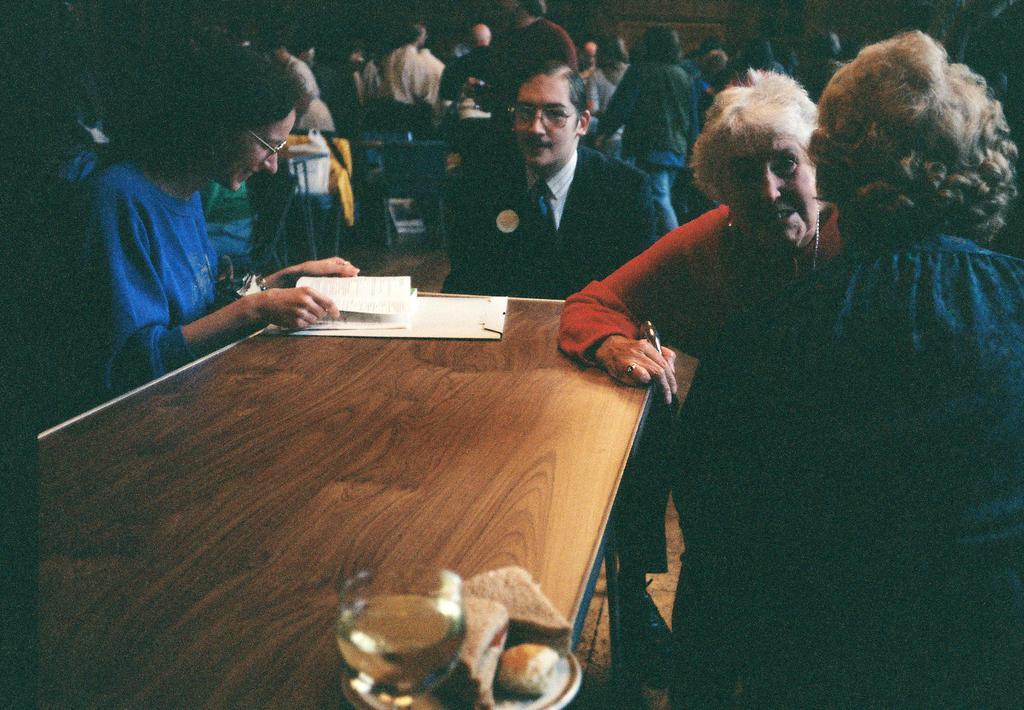In one or two sentences, can you explain what this image depicts? In this image we can see a few people sitting around a table in which two of them are wearing goggles, there we can books, some food item and a glass with some drink on the table, there we can see a few people behind them. 